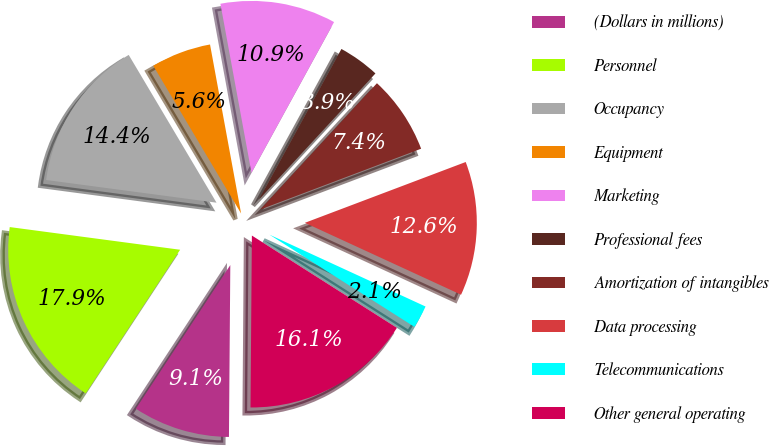<chart> <loc_0><loc_0><loc_500><loc_500><pie_chart><fcel>(Dollars in millions)<fcel>Personnel<fcel>Occupancy<fcel>Equipment<fcel>Marketing<fcel>Professional fees<fcel>Amortization of intangibles<fcel>Data processing<fcel>Telecommunications<fcel>Other general operating<nl><fcel>9.13%<fcel>17.85%<fcel>14.36%<fcel>5.64%<fcel>10.87%<fcel>3.89%<fcel>7.38%<fcel>12.62%<fcel>2.15%<fcel>16.11%<nl></chart> 